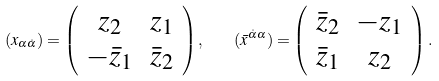Convert formula to latex. <formula><loc_0><loc_0><loc_500><loc_500>( x _ { \alpha \dot { \alpha } } ) = \left ( \begin{array} { c c } { { z _ { 2 } } } & { { z _ { 1 } } } \\ { { - \bar { z } _ { 1 } } } & { { \bar { z } _ { 2 } } } \end{array} \right ) , \quad ( \bar { x } ^ { \dot { \alpha } \alpha } ) = \left ( \begin{array} { c c } { { \bar { z } _ { 2 } } } & { { - z _ { 1 } } } \\ { { \bar { z } _ { 1 } } } & { { z _ { 2 } } } \end{array} \right ) .</formula> 